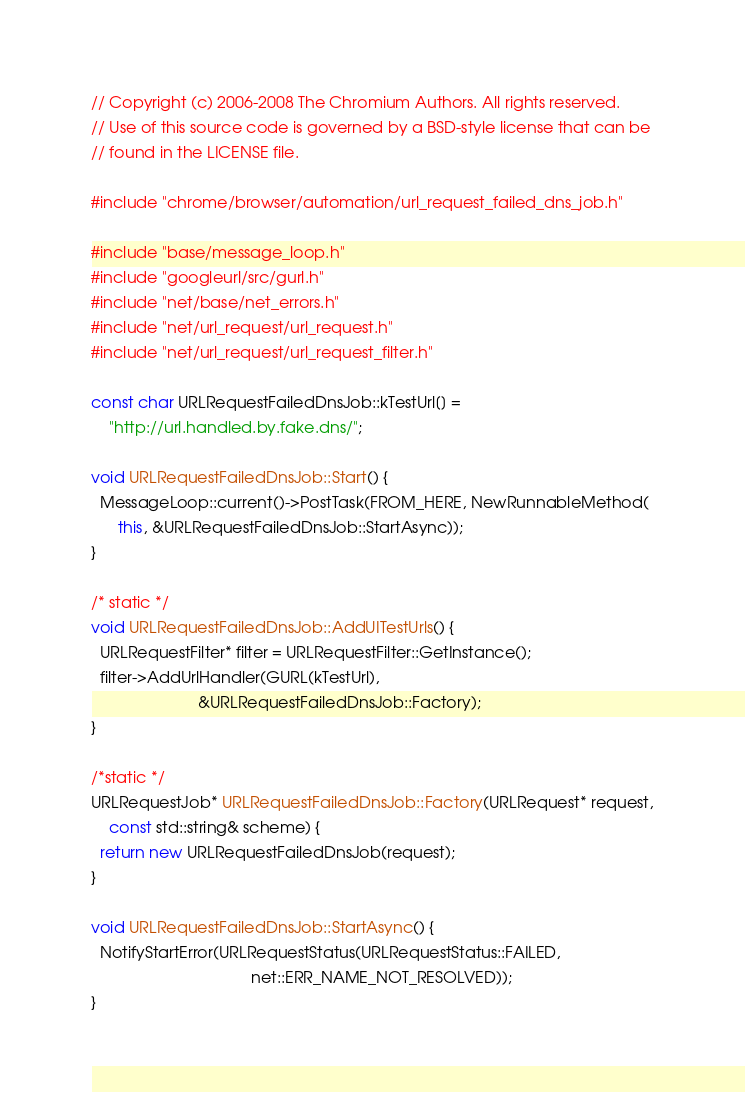Convert code to text. <code><loc_0><loc_0><loc_500><loc_500><_C++_>// Copyright (c) 2006-2008 The Chromium Authors. All rights reserved.
// Use of this source code is governed by a BSD-style license that can be
// found in the LICENSE file.

#include "chrome/browser/automation/url_request_failed_dns_job.h"

#include "base/message_loop.h"
#include "googleurl/src/gurl.h"
#include "net/base/net_errors.h"
#include "net/url_request/url_request.h"
#include "net/url_request/url_request_filter.h"

const char URLRequestFailedDnsJob::kTestUrl[] =
    "http://url.handled.by.fake.dns/";

void URLRequestFailedDnsJob::Start() {
  MessageLoop::current()->PostTask(FROM_HERE, NewRunnableMethod(
      this, &URLRequestFailedDnsJob::StartAsync));
}

/* static */
void URLRequestFailedDnsJob::AddUITestUrls() {
  URLRequestFilter* filter = URLRequestFilter::GetInstance();
  filter->AddUrlHandler(GURL(kTestUrl),
                        &URLRequestFailedDnsJob::Factory);
}

/*static */
URLRequestJob* URLRequestFailedDnsJob::Factory(URLRequest* request,
    const std::string& scheme) {
  return new URLRequestFailedDnsJob(request);
}

void URLRequestFailedDnsJob::StartAsync() {
  NotifyStartError(URLRequestStatus(URLRequestStatus::FAILED,
                                    net::ERR_NAME_NOT_RESOLVED));
}
</code> 